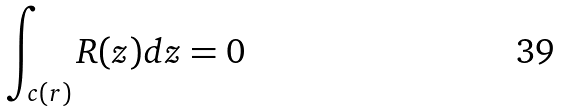<formula> <loc_0><loc_0><loc_500><loc_500>\int _ { c ( r ) } R ( z ) d z = 0</formula> 